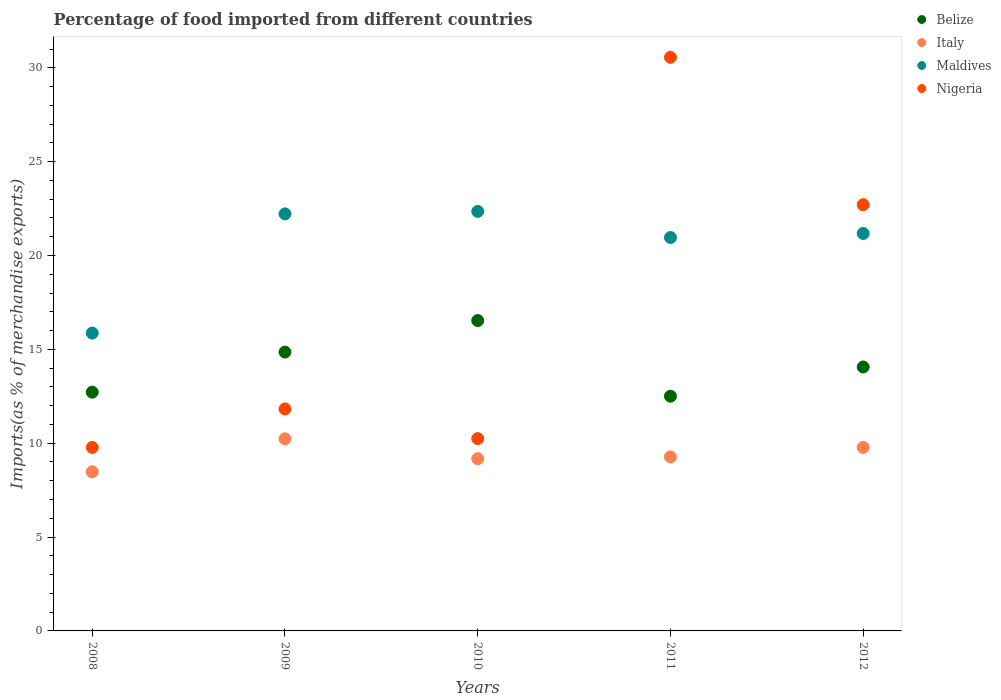Is the number of dotlines equal to the number of legend labels?
Give a very brief answer. Yes. What is the percentage of imports to different countries in Maldives in 2012?
Your answer should be compact. 21.18. Across all years, what is the maximum percentage of imports to different countries in Maldives?
Your answer should be compact. 22.35. Across all years, what is the minimum percentage of imports to different countries in Belize?
Provide a succinct answer. 12.5. What is the total percentage of imports to different countries in Italy in the graph?
Give a very brief answer. 46.94. What is the difference between the percentage of imports to different countries in Belize in 2009 and that in 2010?
Keep it short and to the point. -1.68. What is the difference between the percentage of imports to different countries in Belize in 2011 and the percentage of imports to different countries in Nigeria in 2012?
Offer a terse response. -10.2. What is the average percentage of imports to different countries in Belize per year?
Offer a very short reply. 14.14. In the year 2012, what is the difference between the percentage of imports to different countries in Italy and percentage of imports to different countries in Nigeria?
Make the answer very short. -12.93. What is the ratio of the percentage of imports to different countries in Belize in 2009 to that in 2010?
Give a very brief answer. 0.9. What is the difference between the highest and the second highest percentage of imports to different countries in Nigeria?
Keep it short and to the point. 7.85. What is the difference between the highest and the lowest percentage of imports to different countries in Italy?
Keep it short and to the point. 1.76. In how many years, is the percentage of imports to different countries in Belize greater than the average percentage of imports to different countries in Belize taken over all years?
Offer a terse response. 2. Does the percentage of imports to different countries in Nigeria monotonically increase over the years?
Provide a short and direct response. No. How many dotlines are there?
Make the answer very short. 4. What is the difference between two consecutive major ticks on the Y-axis?
Provide a succinct answer. 5. Does the graph contain any zero values?
Provide a short and direct response. No. How are the legend labels stacked?
Your answer should be very brief. Vertical. What is the title of the graph?
Offer a terse response. Percentage of food imported from different countries. What is the label or title of the X-axis?
Ensure brevity in your answer.  Years. What is the label or title of the Y-axis?
Give a very brief answer. Imports(as % of merchandise exports). What is the Imports(as % of merchandise exports) of Belize in 2008?
Your answer should be very brief. 12.72. What is the Imports(as % of merchandise exports) of Italy in 2008?
Offer a very short reply. 8.48. What is the Imports(as % of merchandise exports) in Maldives in 2008?
Keep it short and to the point. 15.87. What is the Imports(as % of merchandise exports) in Nigeria in 2008?
Give a very brief answer. 9.78. What is the Imports(as % of merchandise exports) of Belize in 2009?
Your answer should be very brief. 14.86. What is the Imports(as % of merchandise exports) in Italy in 2009?
Your response must be concise. 10.24. What is the Imports(as % of merchandise exports) in Maldives in 2009?
Your response must be concise. 22.22. What is the Imports(as % of merchandise exports) of Nigeria in 2009?
Keep it short and to the point. 11.83. What is the Imports(as % of merchandise exports) of Belize in 2010?
Offer a terse response. 16.54. What is the Imports(as % of merchandise exports) of Italy in 2010?
Offer a terse response. 9.18. What is the Imports(as % of merchandise exports) in Maldives in 2010?
Provide a short and direct response. 22.35. What is the Imports(as % of merchandise exports) in Nigeria in 2010?
Offer a terse response. 10.25. What is the Imports(as % of merchandise exports) of Belize in 2011?
Offer a very short reply. 12.5. What is the Imports(as % of merchandise exports) of Italy in 2011?
Your answer should be compact. 9.27. What is the Imports(as % of merchandise exports) in Maldives in 2011?
Provide a short and direct response. 20.96. What is the Imports(as % of merchandise exports) in Nigeria in 2011?
Provide a short and direct response. 30.56. What is the Imports(as % of merchandise exports) of Belize in 2012?
Make the answer very short. 14.06. What is the Imports(as % of merchandise exports) in Italy in 2012?
Provide a succinct answer. 9.78. What is the Imports(as % of merchandise exports) of Maldives in 2012?
Make the answer very short. 21.18. What is the Imports(as % of merchandise exports) in Nigeria in 2012?
Your answer should be compact. 22.71. Across all years, what is the maximum Imports(as % of merchandise exports) in Belize?
Your answer should be very brief. 16.54. Across all years, what is the maximum Imports(as % of merchandise exports) in Italy?
Offer a terse response. 10.24. Across all years, what is the maximum Imports(as % of merchandise exports) of Maldives?
Offer a terse response. 22.35. Across all years, what is the maximum Imports(as % of merchandise exports) in Nigeria?
Your answer should be very brief. 30.56. Across all years, what is the minimum Imports(as % of merchandise exports) in Belize?
Give a very brief answer. 12.5. Across all years, what is the minimum Imports(as % of merchandise exports) in Italy?
Your response must be concise. 8.48. Across all years, what is the minimum Imports(as % of merchandise exports) of Maldives?
Your answer should be very brief. 15.87. Across all years, what is the minimum Imports(as % of merchandise exports) of Nigeria?
Ensure brevity in your answer.  9.78. What is the total Imports(as % of merchandise exports) in Belize in the graph?
Ensure brevity in your answer.  70.68. What is the total Imports(as % of merchandise exports) of Italy in the graph?
Your answer should be compact. 46.94. What is the total Imports(as % of merchandise exports) in Maldives in the graph?
Offer a very short reply. 102.58. What is the total Imports(as % of merchandise exports) of Nigeria in the graph?
Your answer should be very brief. 85.12. What is the difference between the Imports(as % of merchandise exports) of Belize in 2008 and that in 2009?
Keep it short and to the point. -2.13. What is the difference between the Imports(as % of merchandise exports) of Italy in 2008 and that in 2009?
Your response must be concise. -1.76. What is the difference between the Imports(as % of merchandise exports) in Maldives in 2008 and that in 2009?
Make the answer very short. -6.35. What is the difference between the Imports(as % of merchandise exports) in Nigeria in 2008 and that in 2009?
Provide a succinct answer. -2.05. What is the difference between the Imports(as % of merchandise exports) of Belize in 2008 and that in 2010?
Provide a succinct answer. -3.81. What is the difference between the Imports(as % of merchandise exports) of Italy in 2008 and that in 2010?
Give a very brief answer. -0.7. What is the difference between the Imports(as % of merchandise exports) in Maldives in 2008 and that in 2010?
Keep it short and to the point. -6.48. What is the difference between the Imports(as % of merchandise exports) of Nigeria in 2008 and that in 2010?
Your response must be concise. -0.47. What is the difference between the Imports(as % of merchandise exports) of Belize in 2008 and that in 2011?
Your response must be concise. 0.22. What is the difference between the Imports(as % of merchandise exports) in Italy in 2008 and that in 2011?
Give a very brief answer. -0.79. What is the difference between the Imports(as % of merchandise exports) in Maldives in 2008 and that in 2011?
Make the answer very short. -5.09. What is the difference between the Imports(as % of merchandise exports) of Nigeria in 2008 and that in 2011?
Offer a very short reply. -20.78. What is the difference between the Imports(as % of merchandise exports) in Belize in 2008 and that in 2012?
Your answer should be very brief. -1.34. What is the difference between the Imports(as % of merchandise exports) in Italy in 2008 and that in 2012?
Give a very brief answer. -1.3. What is the difference between the Imports(as % of merchandise exports) in Maldives in 2008 and that in 2012?
Keep it short and to the point. -5.31. What is the difference between the Imports(as % of merchandise exports) of Nigeria in 2008 and that in 2012?
Ensure brevity in your answer.  -12.93. What is the difference between the Imports(as % of merchandise exports) of Belize in 2009 and that in 2010?
Provide a short and direct response. -1.68. What is the difference between the Imports(as % of merchandise exports) of Italy in 2009 and that in 2010?
Make the answer very short. 1.06. What is the difference between the Imports(as % of merchandise exports) of Maldives in 2009 and that in 2010?
Offer a terse response. -0.13. What is the difference between the Imports(as % of merchandise exports) of Nigeria in 2009 and that in 2010?
Your response must be concise. 1.58. What is the difference between the Imports(as % of merchandise exports) in Belize in 2009 and that in 2011?
Provide a short and direct response. 2.35. What is the difference between the Imports(as % of merchandise exports) in Italy in 2009 and that in 2011?
Offer a terse response. 0.96. What is the difference between the Imports(as % of merchandise exports) of Maldives in 2009 and that in 2011?
Your response must be concise. 1.26. What is the difference between the Imports(as % of merchandise exports) in Nigeria in 2009 and that in 2011?
Keep it short and to the point. -18.73. What is the difference between the Imports(as % of merchandise exports) in Belize in 2009 and that in 2012?
Offer a very short reply. 0.79. What is the difference between the Imports(as % of merchandise exports) in Italy in 2009 and that in 2012?
Provide a succinct answer. 0.46. What is the difference between the Imports(as % of merchandise exports) of Maldives in 2009 and that in 2012?
Your response must be concise. 1.04. What is the difference between the Imports(as % of merchandise exports) in Nigeria in 2009 and that in 2012?
Offer a terse response. -10.88. What is the difference between the Imports(as % of merchandise exports) of Belize in 2010 and that in 2011?
Provide a short and direct response. 4.03. What is the difference between the Imports(as % of merchandise exports) of Italy in 2010 and that in 2011?
Provide a short and direct response. -0.09. What is the difference between the Imports(as % of merchandise exports) in Maldives in 2010 and that in 2011?
Make the answer very short. 1.39. What is the difference between the Imports(as % of merchandise exports) in Nigeria in 2010 and that in 2011?
Make the answer very short. -20.31. What is the difference between the Imports(as % of merchandise exports) in Belize in 2010 and that in 2012?
Offer a very short reply. 2.47. What is the difference between the Imports(as % of merchandise exports) in Italy in 2010 and that in 2012?
Make the answer very short. -0.6. What is the difference between the Imports(as % of merchandise exports) in Maldives in 2010 and that in 2012?
Your response must be concise. 1.18. What is the difference between the Imports(as % of merchandise exports) in Nigeria in 2010 and that in 2012?
Your answer should be compact. -12.46. What is the difference between the Imports(as % of merchandise exports) of Belize in 2011 and that in 2012?
Your answer should be compact. -1.56. What is the difference between the Imports(as % of merchandise exports) of Italy in 2011 and that in 2012?
Your answer should be compact. -0.51. What is the difference between the Imports(as % of merchandise exports) in Maldives in 2011 and that in 2012?
Your response must be concise. -0.22. What is the difference between the Imports(as % of merchandise exports) in Nigeria in 2011 and that in 2012?
Offer a very short reply. 7.85. What is the difference between the Imports(as % of merchandise exports) of Belize in 2008 and the Imports(as % of merchandise exports) of Italy in 2009?
Your answer should be very brief. 2.49. What is the difference between the Imports(as % of merchandise exports) in Belize in 2008 and the Imports(as % of merchandise exports) in Maldives in 2009?
Give a very brief answer. -9.5. What is the difference between the Imports(as % of merchandise exports) of Belize in 2008 and the Imports(as % of merchandise exports) of Nigeria in 2009?
Ensure brevity in your answer.  0.89. What is the difference between the Imports(as % of merchandise exports) in Italy in 2008 and the Imports(as % of merchandise exports) in Maldives in 2009?
Your response must be concise. -13.74. What is the difference between the Imports(as % of merchandise exports) of Italy in 2008 and the Imports(as % of merchandise exports) of Nigeria in 2009?
Offer a terse response. -3.35. What is the difference between the Imports(as % of merchandise exports) of Maldives in 2008 and the Imports(as % of merchandise exports) of Nigeria in 2009?
Keep it short and to the point. 4.04. What is the difference between the Imports(as % of merchandise exports) in Belize in 2008 and the Imports(as % of merchandise exports) in Italy in 2010?
Your answer should be compact. 3.54. What is the difference between the Imports(as % of merchandise exports) of Belize in 2008 and the Imports(as % of merchandise exports) of Maldives in 2010?
Provide a short and direct response. -9.63. What is the difference between the Imports(as % of merchandise exports) of Belize in 2008 and the Imports(as % of merchandise exports) of Nigeria in 2010?
Offer a very short reply. 2.47. What is the difference between the Imports(as % of merchandise exports) of Italy in 2008 and the Imports(as % of merchandise exports) of Maldives in 2010?
Provide a short and direct response. -13.87. What is the difference between the Imports(as % of merchandise exports) in Italy in 2008 and the Imports(as % of merchandise exports) in Nigeria in 2010?
Provide a succinct answer. -1.77. What is the difference between the Imports(as % of merchandise exports) in Maldives in 2008 and the Imports(as % of merchandise exports) in Nigeria in 2010?
Give a very brief answer. 5.62. What is the difference between the Imports(as % of merchandise exports) in Belize in 2008 and the Imports(as % of merchandise exports) in Italy in 2011?
Your answer should be very brief. 3.45. What is the difference between the Imports(as % of merchandise exports) in Belize in 2008 and the Imports(as % of merchandise exports) in Maldives in 2011?
Your response must be concise. -8.24. What is the difference between the Imports(as % of merchandise exports) of Belize in 2008 and the Imports(as % of merchandise exports) of Nigeria in 2011?
Your answer should be very brief. -17.84. What is the difference between the Imports(as % of merchandise exports) of Italy in 2008 and the Imports(as % of merchandise exports) of Maldives in 2011?
Your answer should be very brief. -12.48. What is the difference between the Imports(as % of merchandise exports) in Italy in 2008 and the Imports(as % of merchandise exports) in Nigeria in 2011?
Offer a terse response. -22.08. What is the difference between the Imports(as % of merchandise exports) in Maldives in 2008 and the Imports(as % of merchandise exports) in Nigeria in 2011?
Your response must be concise. -14.69. What is the difference between the Imports(as % of merchandise exports) in Belize in 2008 and the Imports(as % of merchandise exports) in Italy in 2012?
Your response must be concise. 2.94. What is the difference between the Imports(as % of merchandise exports) in Belize in 2008 and the Imports(as % of merchandise exports) in Maldives in 2012?
Your answer should be very brief. -8.45. What is the difference between the Imports(as % of merchandise exports) of Belize in 2008 and the Imports(as % of merchandise exports) of Nigeria in 2012?
Give a very brief answer. -9.99. What is the difference between the Imports(as % of merchandise exports) in Italy in 2008 and the Imports(as % of merchandise exports) in Maldives in 2012?
Your answer should be compact. -12.7. What is the difference between the Imports(as % of merchandise exports) of Italy in 2008 and the Imports(as % of merchandise exports) of Nigeria in 2012?
Your answer should be very brief. -14.23. What is the difference between the Imports(as % of merchandise exports) of Maldives in 2008 and the Imports(as % of merchandise exports) of Nigeria in 2012?
Make the answer very short. -6.84. What is the difference between the Imports(as % of merchandise exports) in Belize in 2009 and the Imports(as % of merchandise exports) in Italy in 2010?
Keep it short and to the point. 5.68. What is the difference between the Imports(as % of merchandise exports) of Belize in 2009 and the Imports(as % of merchandise exports) of Maldives in 2010?
Provide a short and direct response. -7.5. What is the difference between the Imports(as % of merchandise exports) of Belize in 2009 and the Imports(as % of merchandise exports) of Nigeria in 2010?
Ensure brevity in your answer.  4.61. What is the difference between the Imports(as % of merchandise exports) in Italy in 2009 and the Imports(as % of merchandise exports) in Maldives in 2010?
Ensure brevity in your answer.  -12.12. What is the difference between the Imports(as % of merchandise exports) of Italy in 2009 and the Imports(as % of merchandise exports) of Nigeria in 2010?
Offer a very short reply. -0.01. What is the difference between the Imports(as % of merchandise exports) of Maldives in 2009 and the Imports(as % of merchandise exports) of Nigeria in 2010?
Offer a very short reply. 11.97. What is the difference between the Imports(as % of merchandise exports) in Belize in 2009 and the Imports(as % of merchandise exports) in Italy in 2011?
Ensure brevity in your answer.  5.58. What is the difference between the Imports(as % of merchandise exports) of Belize in 2009 and the Imports(as % of merchandise exports) of Maldives in 2011?
Provide a short and direct response. -6.1. What is the difference between the Imports(as % of merchandise exports) in Belize in 2009 and the Imports(as % of merchandise exports) in Nigeria in 2011?
Offer a very short reply. -15.71. What is the difference between the Imports(as % of merchandise exports) of Italy in 2009 and the Imports(as % of merchandise exports) of Maldives in 2011?
Keep it short and to the point. -10.72. What is the difference between the Imports(as % of merchandise exports) in Italy in 2009 and the Imports(as % of merchandise exports) in Nigeria in 2011?
Provide a succinct answer. -20.33. What is the difference between the Imports(as % of merchandise exports) of Maldives in 2009 and the Imports(as % of merchandise exports) of Nigeria in 2011?
Provide a succinct answer. -8.34. What is the difference between the Imports(as % of merchandise exports) in Belize in 2009 and the Imports(as % of merchandise exports) in Italy in 2012?
Give a very brief answer. 5.08. What is the difference between the Imports(as % of merchandise exports) of Belize in 2009 and the Imports(as % of merchandise exports) of Maldives in 2012?
Ensure brevity in your answer.  -6.32. What is the difference between the Imports(as % of merchandise exports) of Belize in 2009 and the Imports(as % of merchandise exports) of Nigeria in 2012?
Your response must be concise. -7.85. What is the difference between the Imports(as % of merchandise exports) of Italy in 2009 and the Imports(as % of merchandise exports) of Maldives in 2012?
Make the answer very short. -10.94. What is the difference between the Imports(as % of merchandise exports) in Italy in 2009 and the Imports(as % of merchandise exports) in Nigeria in 2012?
Keep it short and to the point. -12.47. What is the difference between the Imports(as % of merchandise exports) of Maldives in 2009 and the Imports(as % of merchandise exports) of Nigeria in 2012?
Offer a terse response. -0.49. What is the difference between the Imports(as % of merchandise exports) of Belize in 2010 and the Imports(as % of merchandise exports) of Italy in 2011?
Make the answer very short. 7.26. What is the difference between the Imports(as % of merchandise exports) in Belize in 2010 and the Imports(as % of merchandise exports) in Maldives in 2011?
Make the answer very short. -4.42. What is the difference between the Imports(as % of merchandise exports) in Belize in 2010 and the Imports(as % of merchandise exports) in Nigeria in 2011?
Give a very brief answer. -14.03. What is the difference between the Imports(as % of merchandise exports) of Italy in 2010 and the Imports(as % of merchandise exports) of Maldives in 2011?
Make the answer very short. -11.78. What is the difference between the Imports(as % of merchandise exports) of Italy in 2010 and the Imports(as % of merchandise exports) of Nigeria in 2011?
Keep it short and to the point. -21.38. What is the difference between the Imports(as % of merchandise exports) in Maldives in 2010 and the Imports(as % of merchandise exports) in Nigeria in 2011?
Your answer should be compact. -8.21. What is the difference between the Imports(as % of merchandise exports) in Belize in 2010 and the Imports(as % of merchandise exports) in Italy in 2012?
Ensure brevity in your answer.  6.76. What is the difference between the Imports(as % of merchandise exports) of Belize in 2010 and the Imports(as % of merchandise exports) of Maldives in 2012?
Provide a short and direct response. -4.64. What is the difference between the Imports(as % of merchandise exports) of Belize in 2010 and the Imports(as % of merchandise exports) of Nigeria in 2012?
Offer a terse response. -6.17. What is the difference between the Imports(as % of merchandise exports) in Italy in 2010 and the Imports(as % of merchandise exports) in Maldives in 2012?
Give a very brief answer. -12. What is the difference between the Imports(as % of merchandise exports) in Italy in 2010 and the Imports(as % of merchandise exports) in Nigeria in 2012?
Your answer should be very brief. -13.53. What is the difference between the Imports(as % of merchandise exports) of Maldives in 2010 and the Imports(as % of merchandise exports) of Nigeria in 2012?
Provide a succinct answer. -0.36. What is the difference between the Imports(as % of merchandise exports) in Belize in 2011 and the Imports(as % of merchandise exports) in Italy in 2012?
Make the answer very short. 2.73. What is the difference between the Imports(as % of merchandise exports) of Belize in 2011 and the Imports(as % of merchandise exports) of Maldives in 2012?
Give a very brief answer. -8.67. What is the difference between the Imports(as % of merchandise exports) in Belize in 2011 and the Imports(as % of merchandise exports) in Nigeria in 2012?
Your answer should be compact. -10.2. What is the difference between the Imports(as % of merchandise exports) in Italy in 2011 and the Imports(as % of merchandise exports) in Maldives in 2012?
Ensure brevity in your answer.  -11.9. What is the difference between the Imports(as % of merchandise exports) of Italy in 2011 and the Imports(as % of merchandise exports) of Nigeria in 2012?
Offer a very short reply. -13.44. What is the difference between the Imports(as % of merchandise exports) of Maldives in 2011 and the Imports(as % of merchandise exports) of Nigeria in 2012?
Ensure brevity in your answer.  -1.75. What is the average Imports(as % of merchandise exports) of Belize per year?
Offer a terse response. 14.14. What is the average Imports(as % of merchandise exports) in Italy per year?
Make the answer very short. 9.39. What is the average Imports(as % of merchandise exports) in Maldives per year?
Your answer should be very brief. 20.52. What is the average Imports(as % of merchandise exports) of Nigeria per year?
Offer a terse response. 17.02. In the year 2008, what is the difference between the Imports(as % of merchandise exports) of Belize and Imports(as % of merchandise exports) of Italy?
Your answer should be very brief. 4.24. In the year 2008, what is the difference between the Imports(as % of merchandise exports) of Belize and Imports(as % of merchandise exports) of Maldives?
Keep it short and to the point. -3.15. In the year 2008, what is the difference between the Imports(as % of merchandise exports) of Belize and Imports(as % of merchandise exports) of Nigeria?
Provide a short and direct response. 2.94. In the year 2008, what is the difference between the Imports(as % of merchandise exports) in Italy and Imports(as % of merchandise exports) in Maldives?
Keep it short and to the point. -7.39. In the year 2008, what is the difference between the Imports(as % of merchandise exports) of Italy and Imports(as % of merchandise exports) of Nigeria?
Provide a succinct answer. -1.3. In the year 2008, what is the difference between the Imports(as % of merchandise exports) of Maldives and Imports(as % of merchandise exports) of Nigeria?
Provide a short and direct response. 6.09. In the year 2009, what is the difference between the Imports(as % of merchandise exports) of Belize and Imports(as % of merchandise exports) of Italy?
Provide a succinct answer. 4.62. In the year 2009, what is the difference between the Imports(as % of merchandise exports) in Belize and Imports(as % of merchandise exports) in Maldives?
Ensure brevity in your answer.  -7.36. In the year 2009, what is the difference between the Imports(as % of merchandise exports) in Belize and Imports(as % of merchandise exports) in Nigeria?
Offer a terse response. 3.03. In the year 2009, what is the difference between the Imports(as % of merchandise exports) in Italy and Imports(as % of merchandise exports) in Maldives?
Make the answer very short. -11.98. In the year 2009, what is the difference between the Imports(as % of merchandise exports) in Italy and Imports(as % of merchandise exports) in Nigeria?
Provide a short and direct response. -1.59. In the year 2009, what is the difference between the Imports(as % of merchandise exports) of Maldives and Imports(as % of merchandise exports) of Nigeria?
Provide a short and direct response. 10.39. In the year 2010, what is the difference between the Imports(as % of merchandise exports) in Belize and Imports(as % of merchandise exports) in Italy?
Keep it short and to the point. 7.36. In the year 2010, what is the difference between the Imports(as % of merchandise exports) of Belize and Imports(as % of merchandise exports) of Maldives?
Offer a terse response. -5.82. In the year 2010, what is the difference between the Imports(as % of merchandise exports) of Belize and Imports(as % of merchandise exports) of Nigeria?
Provide a short and direct response. 6.29. In the year 2010, what is the difference between the Imports(as % of merchandise exports) of Italy and Imports(as % of merchandise exports) of Maldives?
Offer a very short reply. -13.17. In the year 2010, what is the difference between the Imports(as % of merchandise exports) of Italy and Imports(as % of merchandise exports) of Nigeria?
Provide a succinct answer. -1.07. In the year 2010, what is the difference between the Imports(as % of merchandise exports) of Maldives and Imports(as % of merchandise exports) of Nigeria?
Your response must be concise. 12.1. In the year 2011, what is the difference between the Imports(as % of merchandise exports) in Belize and Imports(as % of merchandise exports) in Italy?
Your answer should be very brief. 3.23. In the year 2011, what is the difference between the Imports(as % of merchandise exports) in Belize and Imports(as % of merchandise exports) in Maldives?
Provide a short and direct response. -8.45. In the year 2011, what is the difference between the Imports(as % of merchandise exports) of Belize and Imports(as % of merchandise exports) of Nigeria?
Your answer should be compact. -18.06. In the year 2011, what is the difference between the Imports(as % of merchandise exports) of Italy and Imports(as % of merchandise exports) of Maldives?
Ensure brevity in your answer.  -11.69. In the year 2011, what is the difference between the Imports(as % of merchandise exports) in Italy and Imports(as % of merchandise exports) in Nigeria?
Offer a very short reply. -21.29. In the year 2011, what is the difference between the Imports(as % of merchandise exports) in Maldives and Imports(as % of merchandise exports) in Nigeria?
Offer a terse response. -9.6. In the year 2012, what is the difference between the Imports(as % of merchandise exports) of Belize and Imports(as % of merchandise exports) of Italy?
Offer a terse response. 4.29. In the year 2012, what is the difference between the Imports(as % of merchandise exports) in Belize and Imports(as % of merchandise exports) in Maldives?
Provide a short and direct response. -7.11. In the year 2012, what is the difference between the Imports(as % of merchandise exports) in Belize and Imports(as % of merchandise exports) in Nigeria?
Make the answer very short. -8.65. In the year 2012, what is the difference between the Imports(as % of merchandise exports) in Italy and Imports(as % of merchandise exports) in Maldives?
Provide a short and direct response. -11.4. In the year 2012, what is the difference between the Imports(as % of merchandise exports) in Italy and Imports(as % of merchandise exports) in Nigeria?
Your answer should be very brief. -12.93. In the year 2012, what is the difference between the Imports(as % of merchandise exports) of Maldives and Imports(as % of merchandise exports) of Nigeria?
Your answer should be compact. -1.53. What is the ratio of the Imports(as % of merchandise exports) of Belize in 2008 to that in 2009?
Your answer should be compact. 0.86. What is the ratio of the Imports(as % of merchandise exports) of Italy in 2008 to that in 2009?
Provide a short and direct response. 0.83. What is the ratio of the Imports(as % of merchandise exports) of Maldives in 2008 to that in 2009?
Your answer should be very brief. 0.71. What is the ratio of the Imports(as % of merchandise exports) in Nigeria in 2008 to that in 2009?
Ensure brevity in your answer.  0.83. What is the ratio of the Imports(as % of merchandise exports) of Belize in 2008 to that in 2010?
Offer a terse response. 0.77. What is the ratio of the Imports(as % of merchandise exports) in Italy in 2008 to that in 2010?
Keep it short and to the point. 0.92. What is the ratio of the Imports(as % of merchandise exports) of Maldives in 2008 to that in 2010?
Provide a succinct answer. 0.71. What is the ratio of the Imports(as % of merchandise exports) in Nigeria in 2008 to that in 2010?
Your answer should be compact. 0.95. What is the ratio of the Imports(as % of merchandise exports) in Belize in 2008 to that in 2011?
Your response must be concise. 1.02. What is the ratio of the Imports(as % of merchandise exports) of Italy in 2008 to that in 2011?
Offer a terse response. 0.91. What is the ratio of the Imports(as % of merchandise exports) of Maldives in 2008 to that in 2011?
Give a very brief answer. 0.76. What is the ratio of the Imports(as % of merchandise exports) of Nigeria in 2008 to that in 2011?
Make the answer very short. 0.32. What is the ratio of the Imports(as % of merchandise exports) of Belize in 2008 to that in 2012?
Make the answer very short. 0.9. What is the ratio of the Imports(as % of merchandise exports) in Italy in 2008 to that in 2012?
Provide a succinct answer. 0.87. What is the ratio of the Imports(as % of merchandise exports) of Maldives in 2008 to that in 2012?
Your answer should be very brief. 0.75. What is the ratio of the Imports(as % of merchandise exports) of Nigeria in 2008 to that in 2012?
Make the answer very short. 0.43. What is the ratio of the Imports(as % of merchandise exports) in Belize in 2009 to that in 2010?
Offer a terse response. 0.9. What is the ratio of the Imports(as % of merchandise exports) of Italy in 2009 to that in 2010?
Keep it short and to the point. 1.12. What is the ratio of the Imports(as % of merchandise exports) in Maldives in 2009 to that in 2010?
Your answer should be compact. 0.99. What is the ratio of the Imports(as % of merchandise exports) of Nigeria in 2009 to that in 2010?
Provide a short and direct response. 1.15. What is the ratio of the Imports(as % of merchandise exports) of Belize in 2009 to that in 2011?
Offer a very short reply. 1.19. What is the ratio of the Imports(as % of merchandise exports) in Italy in 2009 to that in 2011?
Your response must be concise. 1.1. What is the ratio of the Imports(as % of merchandise exports) in Maldives in 2009 to that in 2011?
Your response must be concise. 1.06. What is the ratio of the Imports(as % of merchandise exports) of Nigeria in 2009 to that in 2011?
Your answer should be very brief. 0.39. What is the ratio of the Imports(as % of merchandise exports) in Belize in 2009 to that in 2012?
Provide a short and direct response. 1.06. What is the ratio of the Imports(as % of merchandise exports) of Italy in 2009 to that in 2012?
Offer a terse response. 1.05. What is the ratio of the Imports(as % of merchandise exports) of Maldives in 2009 to that in 2012?
Provide a short and direct response. 1.05. What is the ratio of the Imports(as % of merchandise exports) of Nigeria in 2009 to that in 2012?
Keep it short and to the point. 0.52. What is the ratio of the Imports(as % of merchandise exports) in Belize in 2010 to that in 2011?
Offer a very short reply. 1.32. What is the ratio of the Imports(as % of merchandise exports) of Maldives in 2010 to that in 2011?
Provide a succinct answer. 1.07. What is the ratio of the Imports(as % of merchandise exports) in Nigeria in 2010 to that in 2011?
Give a very brief answer. 0.34. What is the ratio of the Imports(as % of merchandise exports) in Belize in 2010 to that in 2012?
Give a very brief answer. 1.18. What is the ratio of the Imports(as % of merchandise exports) of Italy in 2010 to that in 2012?
Your response must be concise. 0.94. What is the ratio of the Imports(as % of merchandise exports) of Maldives in 2010 to that in 2012?
Give a very brief answer. 1.06. What is the ratio of the Imports(as % of merchandise exports) in Nigeria in 2010 to that in 2012?
Your answer should be compact. 0.45. What is the ratio of the Imports(as % of merchandise exports) in Belize in 2011 to that in 2012?
Your answer should be compact. 0.89. What is the ratio of the Imports(as % of merchandise exports) of Italy in 2011 to that in 2012?
Offer a very short reply. 0.95. What is the ratio of the Imports(as % of merchandise exports) of Nigeria in 2011 to that in 2012?
Ensure brevity in your answer.  1.35. What is the difference between the highest and the second highest Imports(as % of merchandise exports) of Belize?
Keep it short and to the point. 1.68. What is the difference between the highest and the second highest Imports(as % of merchandise exports) in Italy?
Give a very brief answer. 0.46. What is the difference between the highest and the second highest Imports(as % of merchandise exports) of Maldives?
Make the answer very short. 0.13. What is the difference between the highest and the second highest Imports(as % of merchandise exports) of Nigeria?
Offer a terse response. 7.85. What is the difference between the highest and the lowest Imports(as % of merchandise exports) of Belize?
Offer a terse response. 4.03. What is the difference between the highest and the lowest Imports(as % of merchandise exports) in Italy?
Offer a very short reply. 1.76. What is the difference between the highest and the lowest Imports(as % of merchandise exports) in Maldives?
Give a very brief answer. 6.48. What is the difference between the highest and the lowest Imports(as % of merchandise exports) of Nigeria?
Provide a short and direct response. 20.78. 